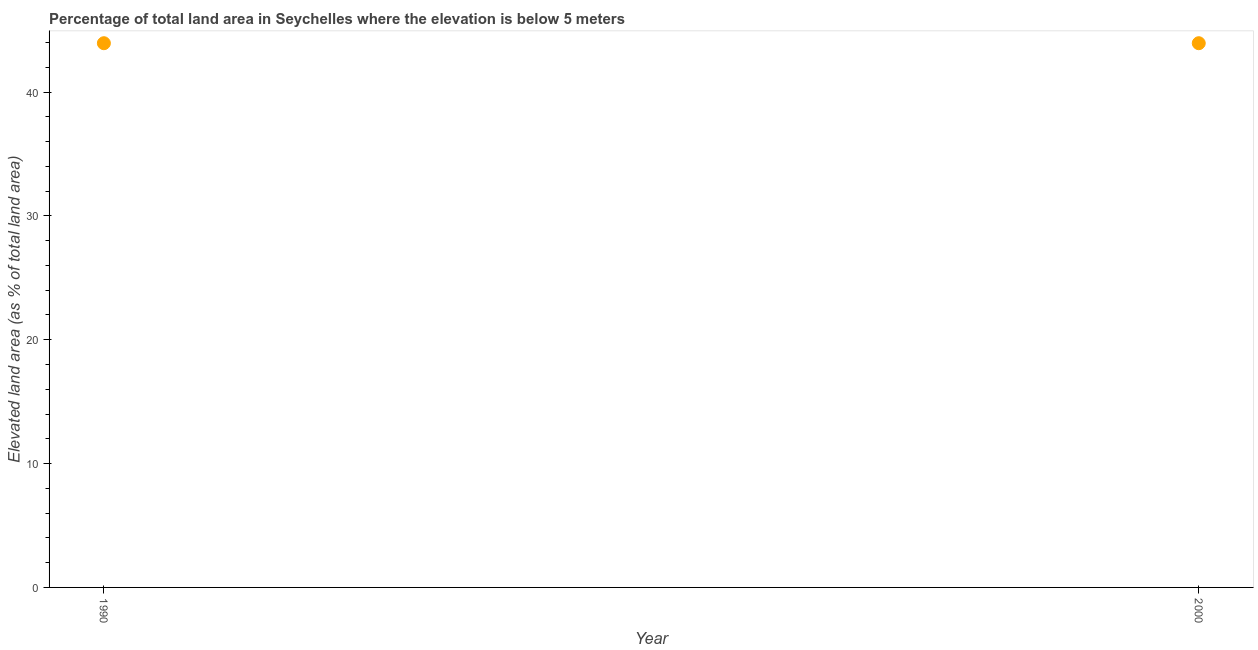What is the total elevated land area in 2000?
Your answer should be compact. 43.94. Across all years, what is the maximum total elevated land area?
Your response must be concise. 43.94. Across all years, what is the minimum total elevated land area?
Your response must be concise. 43.94. What is the sum of the total elevated land area?
Your response must be concise. 87.89. What is the average total elevated land area per year?
Give a very brief answer. 43.94. What is the median total elevated land area?
Provide a short and direct response. 43.94. Is the total elevated land area in 1990 less than that in 2000?
Ensure brevity in your answer.  No. In how many years, is the total elevated land area greater than the average total elevated land area taken over all years?
Offer a very short reply. 0. How many dotlines are there?
Offer a very short reply. 1. How many years are there in the graph?
Your response must be concise. 2. What is the difference between two consecutive major ticks on the Y-axis?
Offer a terse response. 10. Does the graph contain any zero values?
Provide a succinct answer. No. Does the graph contain grids?
Offer a terse response. No. What is the title of the graph?
Give a very brief answer. Percentage of total land area in Seychelles where the elevation is below 5 meters. What is the label or title of the Y-axis?
Your answer should be very brief. Elevated land area (as % of total land area). What is the Elevated land area (as % of total land area) in 1990?
Give a very brief answer. 43.94. What is the Elevated land area (as % of total land area) in 2000?
Your answer should be compact. 43.94. 